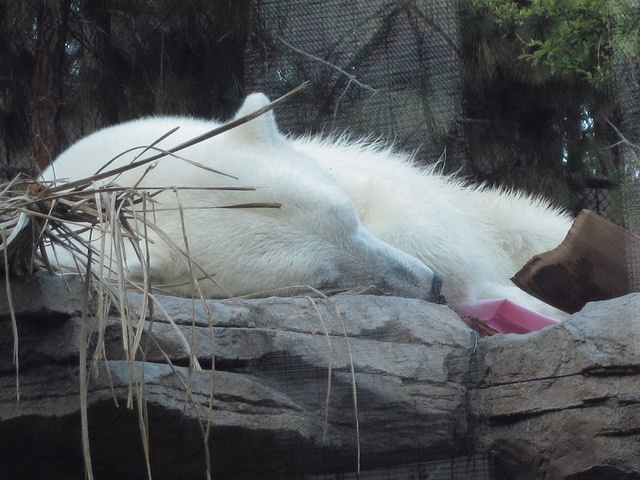Describe the objects in this image and their specific colors. I can see a bear in black, lightgray, darkgray, and gray tones in this image. 